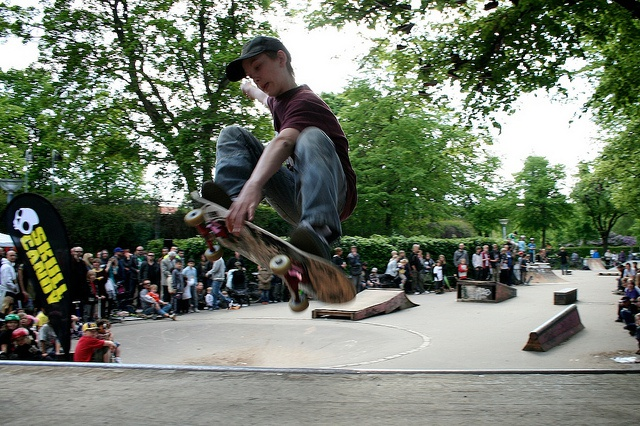Describe the objects in this image and their specific colors. I can see people in white, black, gray, darkgray, and maroon tones, people in white, black, gray, blue, and maroon tones, skateboard in white, black, gray, and maroon tones, people in white, maroon, black, and brown tones, and people in white, black, gray, and darkgray tones in this image. 